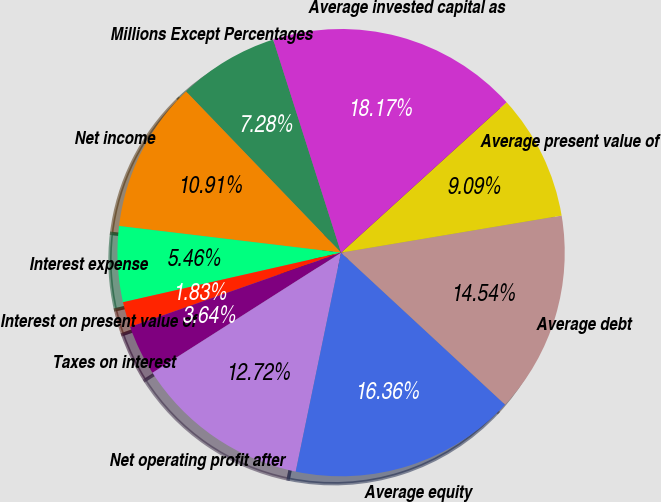Convert chart. <chart><loc_0><loc_0><loc_500><loc_500><pie_chart><fcel>Millions Except Percentages<fcel>Net income<fcel>Interest expense<fcel>Interest on present value of<fcel>Taxes on interest<fcel>Net operating profit after<fcel>Average equity<fcel>Average debt<fcel>Average present value of<fcel>Average invested capital as<nl><fcel>7.28%<fcel>10.91%<fcel>5.46%<fcel>1.83%<fcel>3.64%<fcel>12.72%<fcel>16.36%<fcel>14.54%<fcel>9.09%<fcel>18.17%<nl></chart> 